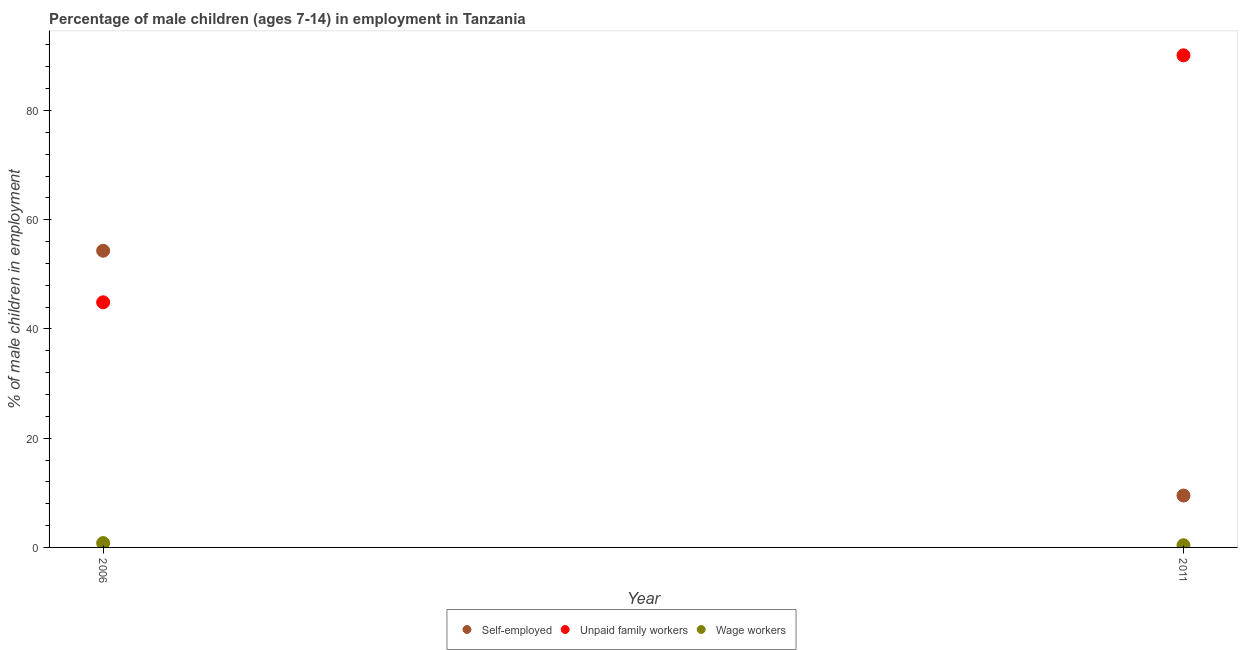How many different coloured dotlines are there?
Your answer should be compact. 3. What is the percentage of children employed as wage workers in 2006?
Offer a terse response. 0.8. Across all years, what is the maximum percentage of children employed as unpaid family workers?
Your answer should be compact. 90.1. Across all years, what is the minimum percentage of children employed as unpaid family workers?
Provide a short and direct response. 44.88. What is the total percentage of children employed as unpaid family workers in the graph?
Offer a terse response. 134.98. What is the difference between the percentage of self employed children in 2006 and that in 2011?
Make the answer very short. 44.82. What is the difference between the percentage of children employed as unpaid family workers in 2011 and the percentage of self employed children in 2006?
Provide a succinct answer. 35.78. What is the average percentage of self employed children per year?
Your response must be concise. 31.91. In the year 2011, what is the difference between the percentage of children employed as unpaid family workers and percentage of children employed as wage workers?
Provide a succinct answer. 89.7. What is the ratio of the percentage of children employed as unpaid family workers in 2006 to that in 2011?
Provide a succinct answer. 0.5. Is the percentage of self employed children in 2006 less than that in 2011?
Ensure brevity in your answer.  No. Is the percentage of self employed children strictly less than the percentage of children employed as unpaid family workers over the years?
Ensure brevity in your answer.  No. How many years are there in the graph?
Provide a short and direct response. 2. What is the difference between two consecutive major ticks on the Y-axis?
Provide a short and direct response. 20. Where does the legend appear in the graph?
Make the answer very short. Bottom center. How many legend labels are there?
Provide a succinct answer. 3. How are the legend labels stacked?
Keep it short and to the point. Horizontal. What is the title of the graph?
Make the answer very short. Percentage of male children (ages 7-14) in employment in Tanzania. Does "Manufactures" appear as one of the legend labels in the graph?
Offer a terse response. No. What is the label or title of the X-axis?
Make the answer very short. Year. What is the label or title of the Y-axis?
Give a very brief answer. % of male children in employment. What is the % of male children in employment in Self-employed in 2006?
Your answer should be very brief. 54.32. What is the % of male children in employment of Unpaid family workers in 2006?
Your response must be concise. 44.88. What is the % of male children in employment in Wage workers in 2006?
Provide a short and direct response. 0.8. What is the % of male children in employment in Self-employed in 2011?
Offer a terse response. 9.5. What is the % of male children in employment in Unpaid family workers in 2011?
Your response must be concise. 90.1. Across all years, what is the maximum % of male children in employment in Self-employed?
Make the answer very short. 54.32. Across all years, what is the maximum % of male children in employment of Unpaid family workers?
Keep it short and to the point. 90.1. Across all years, what is the maximum % of male children in employment in Wage workers?
Your answer should be very brief. 0.8. Across all years, what is the minimum % of male children in employment of Self-employed?
Provide a succinct answer. 9.5. Across all years, what is the minimum % of male children in employment in Unpaid family workers?
Ensure brevity in your answer.  44.88. What is the total % of male children in employment in Self-employed in the graph?
Provide a succinct answer. 63.82. What is the total % of male children in employment in Unpaid family workers in the graph?
Offer a very short reply. 134.98. What is the difference between the % of male children in employment of Self-employed in 2006 and that in 2011?
Offer a terse response. 44.82. What is the difference between the % of male children in employment in Unpaid family workers in 2006 and that in 2011?
Your answer should be compact. -45.22. What is the difference between the % of male children in employment of Wage workers in 2006 and that in 2011?
Your response must be concise. 0.4. What is the difference between the % of male children in employment in Self-employed in 2006 and the % of male children in employment in Unpaid family workers in 2011?
Offer a very short reply. -35.78. What is the difference between the % of male children in employment in Self-employed in 2006 and the % of male children in employment in Wage workers in 2011?
Your answer should be compact. 53.92. What is the difference between the % of male children in employment in Unpaid family workers in 2006 and the % of male children in employment in Wage workers in 2011?
Your answer should be compact. 44.48. What is the average % of male children in employment in Self-employed per year?
Provide a short and direct response. 31.91. What is the average % of male children in employment in Unpaid family workers per year?
Offer a very short reply. 67.49. What is the average % of male children in employment in Wage workers per year?
Offer a terse response. 0.6. In the year 2006, what is the difference between the % of male children in employment in Self-employed and % of male children in employment in Unpaid family workers?
Make the answer very short. 9.44. In the year 2006, what is the difference between the % of male children in employment in Self-employed and % of male children in employment in Wage workers?
Ensure brevity in your answer.  53.52. In the year 2006, what is the difference between the % of male children in employment of Unpaid family workers and % of male children in employment of Wage workers?
Provide a succinct answer. 44.08. In the year 2011, what is the difference between the % of male children in employment of Self-employed and % of male children in employment of Unpaid family workers?
Ensure brevity in your answer.  -80.6. In the year 2011, what is the difference between the % of male children in employment in Self-employed and % of male children in employment in Wage workers?
Provide a succinct answer. 9.1. In the year 2011, what is the difference between the % of male children in employment of Unpaid family workers and % of male children in employment of Wage workers?
Offer a terse response. 89.7. What is the ratio of the % of male children in employment of Self-employed in 2006 to that in 2011?
Make the answer very short. 5.72. What is the ratio of the % of male children in employment in Unpaid family workers in 2006 to that in 2011?
Offer a terse response. 0.5. What is the ratio of the % of male children in employment of Wage workers in 2006 to that in 2011?
Your response must be concise. 2. What is the difference between the highest and the second highest % of male children in employment in Self-employed?
Ensure brevity in your answer.  44.82. What is the difference between the highest and the second highest % of male children in employment in Unpaid family workers?
Offer a terse response. 45.22. What is the difference between the highest and the second highest % of male children in employment in Wage workers?
Your response must be concise. 0.4. What is the difference between the highest and the lowest % of male children in employment in Self-employed?
Your response must be concise. 44.82. What is the difference between the highest and the lowest % of male children in employment in Unpaid family workers?
Your answer should be compact. 45.22. 